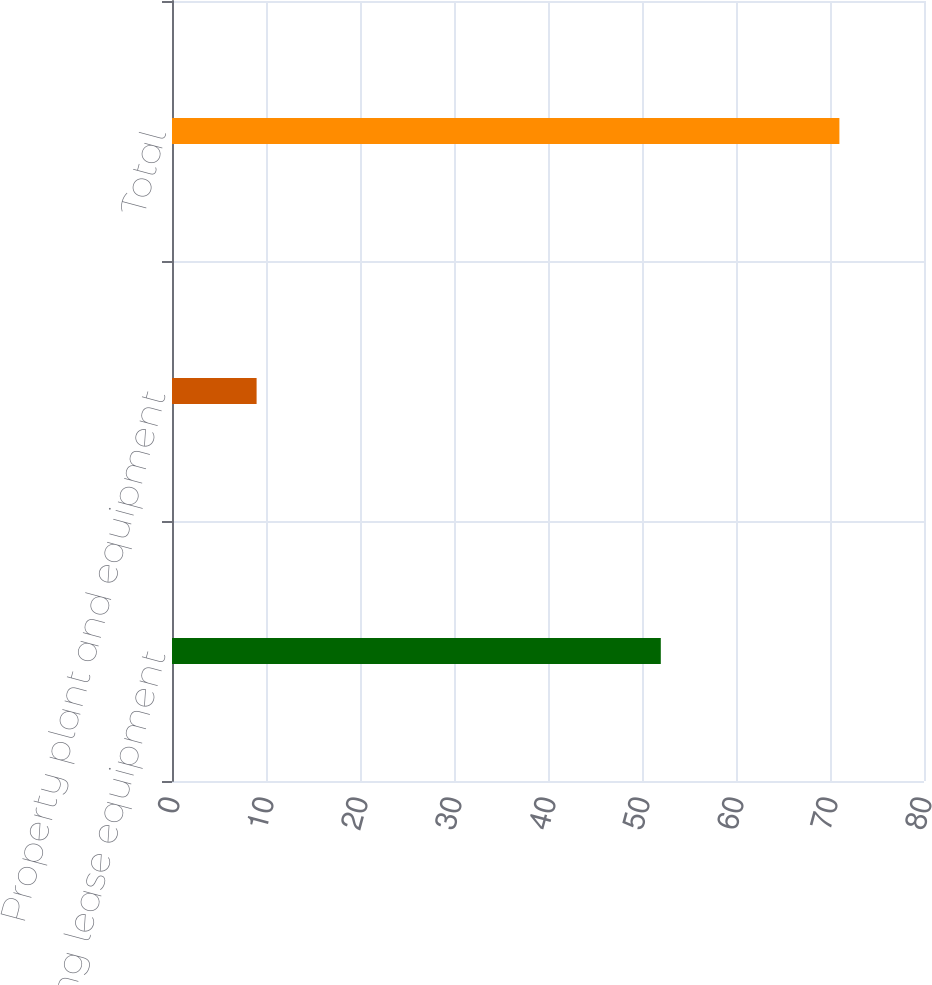Convert chart. <chart><loc_0><loc_0><loc_500><loc_500><bar_chart><fcel>Operating lease equipment<fcel>Property plant and equipment<fcel>Total<nl><fcel>52<fcel>9<fcel>71<nl></chart> 